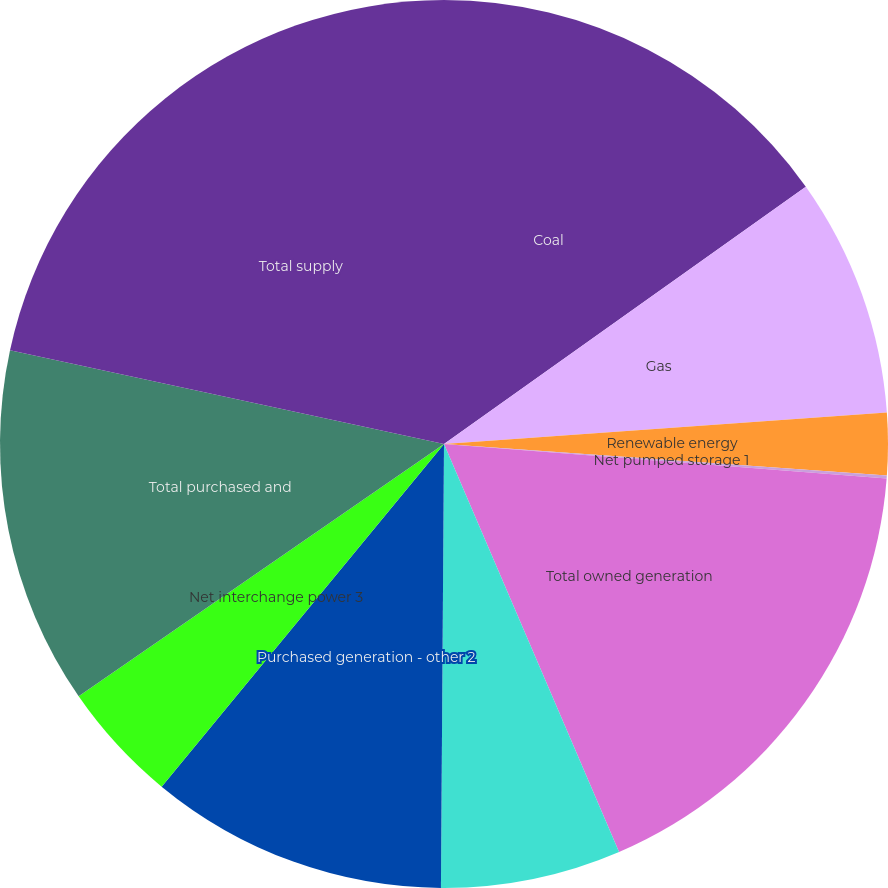Convert chart. <chart><loc_0><loc_0><loc_500><loc_500><pie_chart><fcel>Coal<fcel>Gas<fcel>Renewable energy<fcel>Net pumped storage 1<fcel>Total owned generation<fcel>Purchased renewable energy 2<fcel>Purchased generation - other 2<fcel>Net interchange power 3<fcel>Total purchased and<fcel>Total supply<nl><fcel>15.16%<fcel>8.71%<fcel>2.26%<fcel>0.11%<fcel>17.31%<fcel>6.56%<fcel>10.86%<fcel>4.41%<fcel>13.01%<fcel>21.61%<nl></chart> 